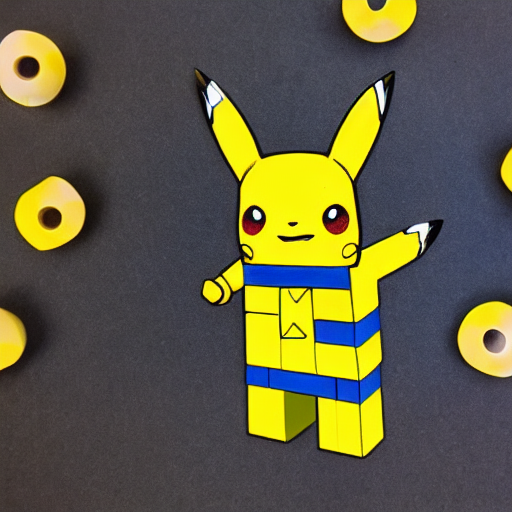Can you describe the use of color in this artwork? Certainly. The artwork utilizes a limited color palette with a dominant yellow that directly references Pikachu's classic color scheme. The use of contrasting blue for the detailing interrupts the monotony and adds a dynamic element to the piece. The overall effect is striking while still maintaining a sense of fun and playfulness. How do the background elements contribute to the overall composition? The background, with its repetitive pattern of yellow shapes, provides a textured backdrop that complements the central figure. These shapes echo the character's color and form, creating unity and rhythm within the composition, and directing the viewer's attention towards the renditions of Pikachu. 